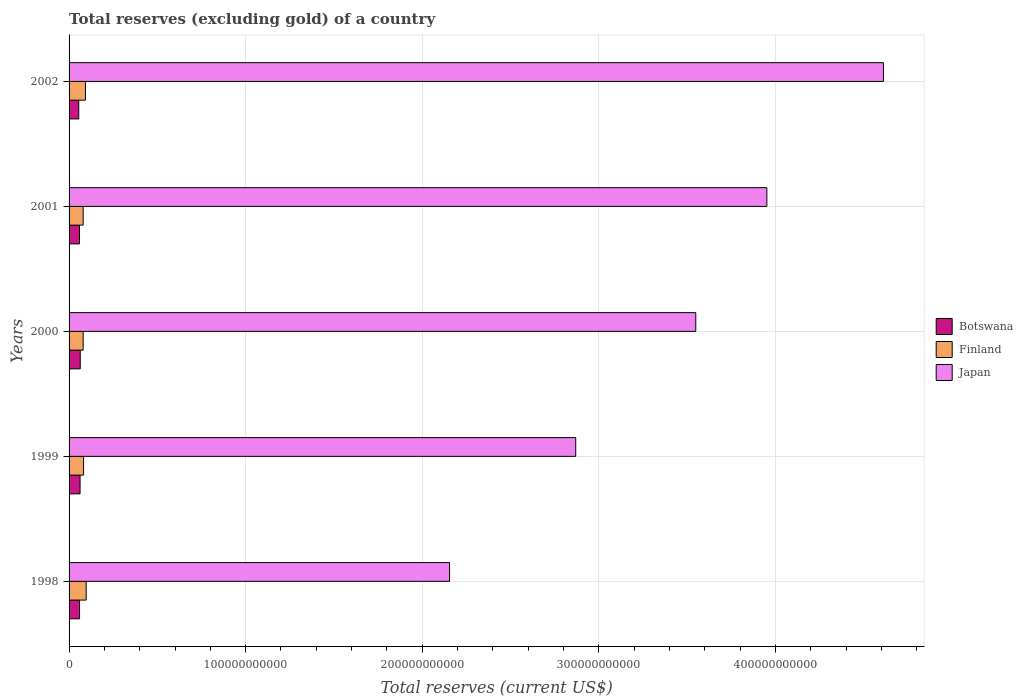Are the number of bars per tick equal to the number of legend labels?
Keep it short and to the point. Yes. How many bars are there on the 5th tick from the bottom?
Offer a very short reply. 3. What is the label of the 4th group of bars from the top?
Offer a very short reply. 1999. In how many cases, is the number of bars for a given year not equal to the number of legend labels?
Make the answer very short. 0. What is the total reserves (excluding gold) in Finland in 1999?
Ensure brevity in your answer.  8.22e+09. Across all years, what is the maximum total reserves (excluding gold) in Finland?
Offer a terse response. 9.69e+09. Across all years, what is the minimum total reserves (excluding gold) in Finland?
Your response must be concise. 7.98e+09. In which year was the total reserves (excluding gold) in Finland maximum?
Your answer should be very brief. 1998. What is the total total reserves (excluding gold) in Botswana in the graph?
Keep it short and to the point. 2.99e+1. What is the difference between the total reserves (excluding gold) in Botswana in 1999 and that in 2000?
Offer a terse response. -8.94e+07. What is the difference between the total reserves (excluding gold) in Japan in 1998 and the total reserves (excluding gold) in Botswana in 2002?
Offer a terse response. 2.10e+11. What is the average total reserves (excluding gold) in Botswana per year?
Your answer should be very brief. 5.97e+09. In the year 1998, what is the difference between the total reserves (excluding gold) in Japan and total reserves (excluding gold) in Botswana?
Ensure brevity in your answer.  2.10e+11. In how many years, is the total reserves (excluding gold) in Botswana greater than 100000000000 US$?
Your response must be concise. 0. What is the ratio of the total reserves (excluding gold) in Botswana in 1998 to that in 1999?
Offer a very short reply. 0.95. Is the difference between the total reserves (excluding gold) in Japan in 1998 and 2001 greater than the difference between the total reserves (excluding gold) in Botswana in 1998 and 2001?
Give a very brief answer. No. What is the difference between the highest and the second highest total reserves (excluding gold) in Finland?
Ensure brevity in your answer.  4.10e+08. What is the difference between the highest and the lowest total reserves (excluding gold) in Botswana?
Provide a succinct answer. 8.44e+08. In how many years, is the total reserves (excluding gold) in Finland greater than the average total reserves (excluding gold) in Finland taken over all years?
Provide a succinct answer. 2. Is the sum of the total reserves (excluding gold) in Japan in 1999 and 2001 greater than the maximum total reserves (excluding gold) in Finland across all years?
Offer a very short reply. Yes. What does the 3rd bar from the top in 1999 represents?
Ensure brevity in your answer.  Botswana. What does the 2nd bar from the bottom in 2000 represents?
Your answer should be very brief. Finland. Is it the case that in every year, the sum of the total reserves (excluding gold) in Botswana and total reserves (excluding gold) in Finland is greater than the total reserves (excluding gold) in Japan?
Give a very brief answer. No. How many bars are there?
Provide a short and direct response. 15. How many years are there in the graph?
Provide a short and direct response. 5. What is the difference between two consecutive major ticks on the X-axis?
Give a very brief answer. 1.00e+11. How are the legend labels stacked?
Your response must be concise. Vertical. What is the title of the graph?
Keep it short and to the point. Total reserves (excluding gold) of a country. What is the label or title of the X-axis?
Keep it short and to the point. Total reserves (current US$). What is the label or title of the Y-axis?
Your answer should be very brief. Years. What is the Total reserves (current US$) of Botswana in 1998?
Your answer should be compact. 5.94e+09. What is the Total reserves (current US$) in Finland in 1998?
Ensure brevity in your answer.  9.69e+09. What is the Total reserves (current US$) of Japan in 1998?
Provide a short and direct response. 2.15e+11. What is the Total reserves (current US$) in Botswana in 1999?
Your response must be concise. 6.23e+09. What is the Total reserves (current US$) in Finland in 1999?
Your response must be concise. 8.22e+09. What is the Total reserves (current US$) of Japan in 1999?
Your answer should be very brief. 2.87e+11. What is the Total reserves (current US$) of Botswana in 2000?
Ensure brevity in your answer.  6.32e+09. What is the Total reserves (current US$) in Finland in 2000?
Ensure brevity in your answer.  7.98e+09. What is the Total reserves (current US$) in Japan in 2000?
Your answer should be very brief. 3.55e+11. What is the Total reserves (current US$) of Botswana in 2001?
Your response must be concise. 5.90e+09. What is the Total reserves (current US$) of Finland in 2001?
Offer a very short reply. 7.98e+09. What is the Total reserves (current US$) of Japan in 2001?
Offer a very short reply. 3.95e+11. What is the Total reserves (current US$) of Botswana in 2002?
Give a very brief answer. 5.47e+09. What is the Total reserves (current US$) of Finland in 2002?
Keep it short and to the point. 9.28e+09. What is the Total reserves (current US$) in Japan in 2002?
Your answer should be compact. 4.61e+11. Across all years, what is the maximum Total reserves (current US$) of Botswana?
Ensure brevity in your answer.  6.32e+09. Across all years, what is the maximum Total reserves (current US$) in Finland?
Your answer should be very brief. 9.69e+09. Across all years, what is the maximum Total reserves (current US$) of Japan?
Provide a short and direct response. 4.61e+11. Across all years, what is the minimum Total reserves (current US$) in Botswana?
Make the answer very short. 5.47e+09. Across all years, what is the minimum Total reserves (current US$) of Finland?
Offer a terse response. 7.98e+09. Across all years, what is the minimum Total reserves (current US$) in Japan?
Ensure brevity in your answer.  2.15e+11. What is the total Total reserves (current US$) in Botswana in the graph?
Your answer should be very brief. 2.99e+1. What is the total Total reserves (current US$) in Finland in the graph?
Your response must be concise. 4.32e+1. What is the total Total reserves (current US$) of Japan in the graph?
Make the answer very short. 1.71e+12. What is the difference between the Total reserves (current US$) of Botswana in 1998 and that in 1999?
Your answer should be very brief. -2.88e+08. What is the difference between the Total reserves (current US$) of Finland in 1998 and that in 1999?
Keep it short and to the point. 1.47e+09. What is the difference between the Total reserves (current US$) of Japan in 1998 and that in 1999?
Offer a terse response. -7.14e+1. What is the difference between the Total reserves (current US$) of Botswana in 1998 and that in 2000?
Give a very brief answer. -3.78e+08. What is the difference between the Total reserves (current US$) in Finland in 1998 and that in 2000?
Your answer should be compact. 1.72e+09. What is the difference between the Total reserves (current US$) of Japan in 1998 and that in 2000?
Ensure brevity in your answer.  -1.39e+11. What is the difference between the Total reserves (current US$) of Botswana in 1998 and that in 2001?
Make the answer very short. 4.34e+07. What is the difference between the Total reserves (current US$) in Finland in 1998 and that in 2001?
Offer a terse response. 1.71e+09. What is the difference between the Total reserves (current US$) in Japan in 1998 and that in 2001?
Provide a short and direct response. -1.80e+11. What is the difference between the Total reserves (current US$) in Botswana in 1998 and that in 2002?
Offer a very short reply. 4.67e+08. What is the difference between the Total reserves (current US$) in Finland in 1998 and that in 2002?
Offer a terse response. 4.10e+08. What is the difference between the Total reserves (current US$) of Japan in 1998 and that in 2002?
Make the answer very short. -2.46e+11. What is the difference between the Total reserves (current US$) in Botswana in 1999 and that in 2000?
Provide a succinct answer. -8.94e+07. What is the difference between the Total reserves (current US$) in Finland in 1999 and that in 2000?
Offer a terse response. 2.43e+08. What is the difference between the Total reserves (current US$) of Japan in 1999 and that in 2000?
Offer a terse response. -6.80e+1. What is the difference between the Total reserves (current US$) of Botswana in 1999 and that in 2001?
Offer a very short reply. 3.32e+08. What is the difference between the Total reserves (current US$) in Finland in 1999 and that in 2001?
Your answer should be very brief. 2.36e+08. What is the difference between the Total reserves (current US$) in Japan in 1999 and that in 2001?
Offer a terse response. -1.08e+11. What is the difference between the Total reserves (current US$) of Botswana in 1999 and that in 2002?
Offer a terse response. 7.55e+08. What is the difference between the Total reserves (current US$) of Finland in 1999 and that in 2002?
Make the answer very short. -1.07e+09. What is the difference between the Total reserves (current US$) in Japan in 1999 and that in 2002?
Offer a terse response. -1.74e+11. What is the difference between the Total reserves (current US$) in Botswana in 2000 and that in 2001?
Your answer should be very brief. 4.21e+08. What is the difference between the Total reserves (current US$) of Finland in 2000 and that in 2001?
Provide a succinct answer. -6.42e+06. What is the difference between the Total reserves (current US$) of Japan in 2000 and that in 2001?
Your answer should be compact. -4.03e+1. What is the difference between the Total reserves (current US$) of Botswana in 2000 and that in 2002?
Give a very brief answer. 8.44e+08. What is the difference between the Total reserves (current US$) in Finland in 2000 and that in 2002?
Give a very brief answer. -1.31e+09. What is the difference between the Total reserves (current US$) in Japan in 2000 and that in 2002?
Keep it short and to the point. -1.06e+11. What is the difference between the Total reserves (current US$) of Botswana in 2001 and that in 2002?
Your response must be concise. 4.23e+08. What is the difference between the Total reserves (current US$) of Finland in 2001 and that in 2002?
Offer a terse response. -1.30e+09. What is the difference between the Total reserves (current US$) in Japan in 2001 and that in 2002?
Provide a short and direct response. -6.60e+1. What is the difference between the Total reserves (current US$) of Botswana in 1998 and the Total reserves (current US$) of Finland in 1999?
Give a very brief answer. -2.28e+09. What is the difference between the Total reserves (current US$) in Botswana in 1998 and the Total reserves (current US$) in Japan in 1999?
Give a very brief answer. -2.81e+11. What is the difference between the Total reserves (current US$) of Finland in 1998 and the Total reserves (current US$) of Japan in 1999?
Keep it short and to the point. -2.77e+11. What is the difference between the Total reserves (current US$) of Botswana in 1998 and the Total reserves (current US$) of Finland in 2000?
Provide a succinct answer. -2.04e+09. What is the difference between the Total reserves (current US$) in Botswana in 1998 and the Total reserves (current US$) in Japan in 2000?
Ensure brevity in your answer.  -3.49e+11. What is the difference between the Total reserves (current US$) in Finland in 1998 and the Total reserves (current US$) in Japan in 2000?
Keep it short and to the point. -3.45e+11. What is the difference between the Total reserves (current US$) in Botswana in 1998 and the Total reserves (current US$) in Finland in 2001?
Offer a terse response. -2.04e+09. What is the difference between the Total reserves (current US$) of Botswana in 1998 and the Total reserves (current US$) of Japan in 2001?
Provide a short and direct response. -3.89e+11. What is the difference between the Total reserves (current US$) in Finland in 1998 and the Total reserves (current US$) in Japan in 2001?
Provide a short and direct response. -3.85e+11. What is the difference between the Total reserves (current US$) in Botswana in 1998 and the Total reserves (current US$) in Finland in 2002?
Your answer should be very brief. -3.34e+09. What is the difference between the Total reserves (current US$) of Botswana in 1998 and the Total reserves (current US$) of Japan in 2002?
Keep it short and to the point. -4.55e+11. What is the difference between the Total reserves (current US$) of Finland in 1998 and the Total reserves (current US$) of Japan in 2002?
Your answer should be very brief. -4.51e+11. What is the difference between the Total reserves (current US$) in Botswana in 1999 and the Total reserves (current US$) in Finland in 2000?
Your answer should be compact. -1.75e+09. What is the difference between the Total reserves (current US$) in Botswana in 1999 and the Total reserves (current US$) in Japan in 2000?
Ensure brevity in your answer.  -3.49e+11. What is the difference between the Total reserves (current US$) in Finland in 1999 and the Total reserves (current US$) in Japan in 2000?
Keep it short and to the point. -3.47e+11. What is the difference between the Total reserves (current US$) in Botswana in 1999 and the Total reserves (current US$) in Finland in 2001?
Offer a very short reply. -1.75e+09. What is the difference between the Total reserves (current US$) in Botswana in 1999 and the Total reserves (current US$) in Japan in 2001?
Offer a terse response. -3.89e+11. What is the difference between the Total reserves (current US$) of Finland in 1999 and the Total reserves (current US$) of Japan in 2001?
Provide a succinct answer. -3.87e+11. What is the difference between the Total reserves (current US$) of Botswana in 1999 and the Total reserves (current US$) of Finland in 2002?
Provide a short and direct response. -3.06e+09. What is the difference between the Total reserves (current US$) in Botswana in 1999 and the Total reserves (current US$) in Japan in 2002?
Offer a very short reply. -4.55e+11. What is the difference between the Total reserves (current US$) in Finland in 1999 and the Total reserves (current US$) in Japan in 2002?
Ensure brevity in your answer.  -4.53e+11. What is the difference between the Total reserves (current US$) of Botswana in 2000 and the Total reserves (current US$) of Finland in 2001?
Offer a terse response. -1.67e+09. What is the difference between the Total reserves (current US$) in Botswana in 2000 and the Total reserves (current US$) in Japan in 2001?
Provide a succinct answer. -3.89e+11. What is the difference between the Total reserves (current US$) in Finland in 2000 and the Total reserves (current US$) in Japan in 2001?
Make the answer very short. -3.87e+11. What is the difference between the Total reserves (current US$) of Botswana in 2000 and the Total reserves (current US$) of Finland in 2002?
Your answer should be compact. -2.97e+09. What is the difference between the Total reserves (current US$) in Botswana in 2000 and the Total reserves (current US$) in Japan in 2002?
Provide a succinct answer. -4.55e+11. What is the difference between the Total reserves (current US$) in Finland in 2000 and the Total reserves (current US$) in Japan in 2002?
Keep it short and to the point. -4.53e+11. What is the difference between the Total reserves (current US$) of Botswana in 2001 and the Total reserves (current US$) of Finland in 2002?
Your answer should be very brief. -3.39e+09. What is the difference between the Total reserves (current US$) in Botswana in 2001 and the Total reserves (current US$) in Japan in 2002?
Ensure brevity in your answer.  -4.55e+11. What is the difference between the Total reserves (current US$) of Finland in 2001 and the Total reserves (current US$) of Japan in 2002?
Your response must be concise. -4.53e+11. What is the average Total reserves (current US$) in Botswana per year?
Offer a terse response. 5.97e+09. What is the average Total reserves (current US$) in Finland per year?
Make the answer very short. 8.63e+09. What is the average Total reserves (current US$) in Japan per year?
Give a very brief answer. 3.43e+11. In the year 1998, what is the difference between the Total reserves (current US$) of Botswana and Total reserves (current US$) of Finland?
Ensure brevity in your answer.  -3.75e+09. In the year 1998, what is the difference between the Total reserves (current US$) of Botswana and Total reserves (current US$) of Japan?
Your response must be concise. -2.10e+11. In the year 1998, what is the difference between the Total reserves (current US$) of Finland and Total reserves (current US$) of Japan?
Provide a short and direct response. -2.06e+11. In the year 1999, what is the difference between the Total reserves (current US$) of Botswana and Total reserves (current US$) of Finland?
Provide a succinct answer. -1.99e+09. In the year 1999, what is the difference between the Total reserves (current US$) in Botswana and Total reserves (current US$) in Japan?
Your answer should be compact. -2.81e+11. In the year 1999, what is the difference between the Total reserves (current US$) of Finland and Total reserves (current US$) of Japan?
Give a very brief answer. -2.79e+11. In the year 2000, what is the difference between the Total reserves (current US$) in Botswana and Total reserves (current US$) in Finland?
Provide a short and direct response. -1.66e+09. In the year 2000, what is the difference between the Total reserves (current US$) in Botswana and Total reserves (current US$) in Japan?
Your response must be concise. -3.49e+11. In the year 2000, what is the difference between the Total reserves (current US$) of Finland and Total reserves (current US$) of Japan?
Offer a very short reply. -3.47e+11. In the year 2001, what is the difference between the Total reserves (current US$) of Botswana and Total reserves (current US$) of Finland?
Give a very brief answer. -2.09e+09. In the year 2001, what is the difference between the Total reserves (current US$) in Botswana and Total reserves (current US$) in Japan?
Keep it short and to the point. -3.89e+11. In the year 2001, what is the difference between the Total reserves (current US$) in Finland and Total reserves (current US$) in Japan?
Ensure brevity in your answer.  -3.87e+11. In the year 2002, what is the difference between the Total reserves (current US$) of Botswana and Total reserves (current US$) of Finland?
Your answer should be compact. -3.81e+09. In the year 2002, what is the difference between the Total reserves (current US$) of Botswana and Total reserves (current US$) of Japan?
Your response must be concise. -4.56e+11. In the year 2002, what is the difference between the Total reserves (current US$) in Finland and Total reserves (current US$) in Japan?
Your answer should be compact. -4.52e+11. What is the ratio of the Total reserves (current US$) in Botswana in 1998 to that in 1999?
Your answer should be very brief. 0.95. What is the ratio of the Total reserves (current US$) in Finland in 1998 to that in 1999?
Provide a succinct answer. 1.18. What is the ratio of the Total reserves (current US$) in Japan in 1998 to that in 1999?
Your response must be concise. 0.75. What is the ratio of the Total reserves (current US$) in Botswana in 1998 to that in 2000?
Your response must be concise. 0.94. What is the ratio of the Total reserves (current US$) in Finland in 1998 to that in 2000?
Keep it short and to the point. 1.22. What is the ratio of the Total reserves (current US$) in Japan in 1998 to that in 2000?
Ensure brevity in your answer.  0.61. What is the ratio of the Total reserves (current US$) of Botswana in 1998 to that in 2001?
Make the answer very short. 1.01. What is the ratio of the Total reserves (current US$) in Finland in 1998 to that in 2001?
Offer a terse response. 1.21. What is the ratio of the Total reserves (current US$) of Japan in 1998 to that in 2001?
Your answer should be compact. 0.55. What is the ratio of the Total reserves (current US$) of Botswana in 1998 to that in 2002?
Your answer should be compact. 1.09. What is the ratio of the Total reserves (current US$) in Finland in 1998 to that in 2002?
Your answer should be compact. 1.04. What is the ratio of the Total reserves (current US$) of Japan in 1998 to that in 2002?
Ensure brevity in your answer.  0.47. What is the ratio of the Total reserves (current US$) of Botswana in 1999 to that in 2000?
Make the answer very short. 0.99. What is the ratio of the Total reserves (current US$) of Finland in 1999 to that in 2000?
Your response must be concise. 1.03. What is the ratio of the Total reserves (current US$) of Japan in 1999 to that in 2000?
Your answer should be very brief. 0.81. What is the ratio of the Total reserves (current US$) in Botswana in 1999 to that in 2001?
Offer a very short reply. 1.06. What is the ratio of the Total reserves (current US$) in Finland in 1999 to that in 2001?
Provide a short and direct response. 1.03. What is the ratio of the Total reserves (current US$) in Japan in 1999 to that in 2001?
Your answer should be very brief. 0.73. What is the ratio of the Total reserves (current US$) in Botswana in 1999 to that in 2002?
Make the answer very short. 1.14. What is the ratio of the Total reserves (current US$) of Finland in 1999 to that in 2002?
Ensure brevity in your answer.  0.89. What is the ratio of the Total reserves (current US$) in Japan in 1999 to that in 2002?
Your response must be concise. 0.62. What is the ratio of the Total reserves (current US$) in Botswana in 2000 to that in 2001?
Keep it short and to the point. 1.07. What is the ratio of the Total reserves (current US$) of Japan in 2000 to that in 2001?
Provide a short and direct response. 0.9. What is the ratio of the Total reserves (current US$) of Botswana in 2000 to that in 2002?
Provide a succinct answer. 1.15. What is the ratio of the Total reserves (current US$) in Finland in 2000 to that in 2002?
Keep it short and to the point. 0.86. What is the ratio of the Total reserves (current US$) of Japan in 2000 to that in 2002?
Offer a very short reply. 0.77. What is the ratio of the Total reserves (current US$) in Botswana in 2001 to that in 2002?
Your answer should be compact. 1.08. What is the ratio of the Total reserves (current US$) of Finland in 2001 to that in 2002?
Your answer should be compact. 0.86. What is the ratio of the Total reserves (current US$) in Japan in 2001 to that in 2002?
Your answer should be compact. 0.86. What is the difference between the highest and the second highest Total reserves (current US$) in Botswana?
Your answer should be very brief. 8.94e+07. What is the difference between the highest and the second highest Total reserves (current US$) of Finland?
Make the answer very short. 4.10e+08. What is the difference between the highest and the second highest Total reserves (current US$) of Japan?
Give a very brief answer. 6.60e+1. What is the difference between the highest and the lowest Total reserves (current US$) of Botswana?
Provide a succinct answer. 8.44e+08. What is the difference between the highest and the lowest Total reserves (current US$) in Finland?
Offer a terse response. 1.72e+09. What is the difference between the highest and the lowest Total reserves (current US$) of Japan?
Make the answer very short. 2.46e+11. 